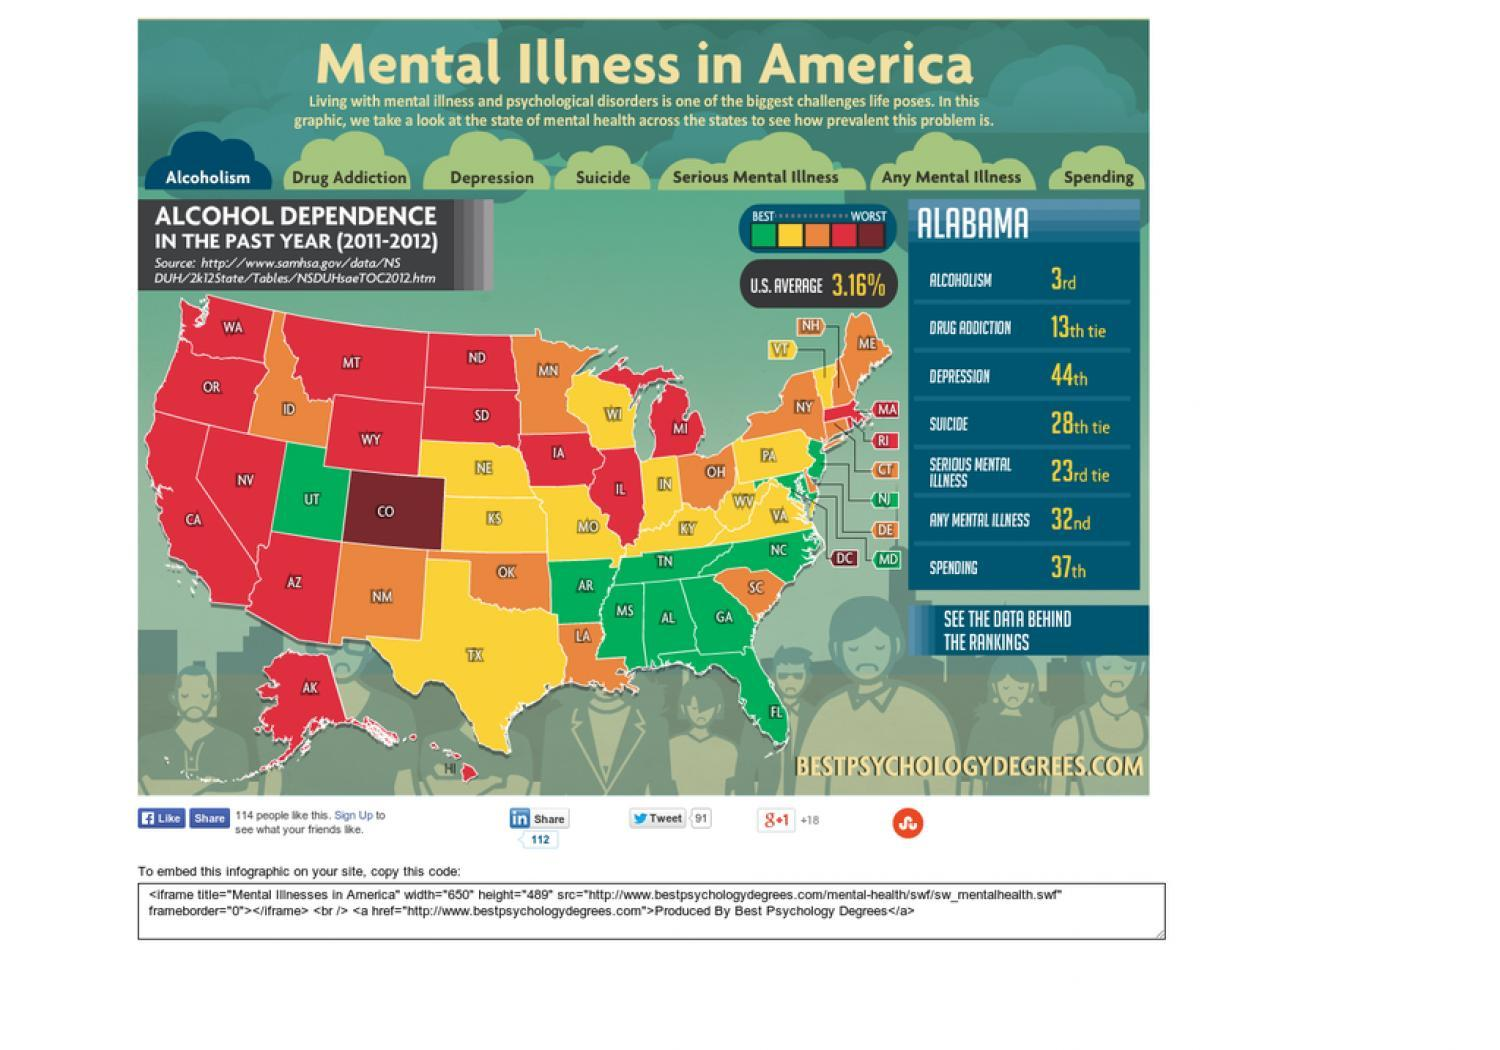Which is the main cause of mental illness as per the document?
Answer the question with a short phrase. Alcoholism How many states are best when it comes to alcohol dependence during 2011-2012? 10 